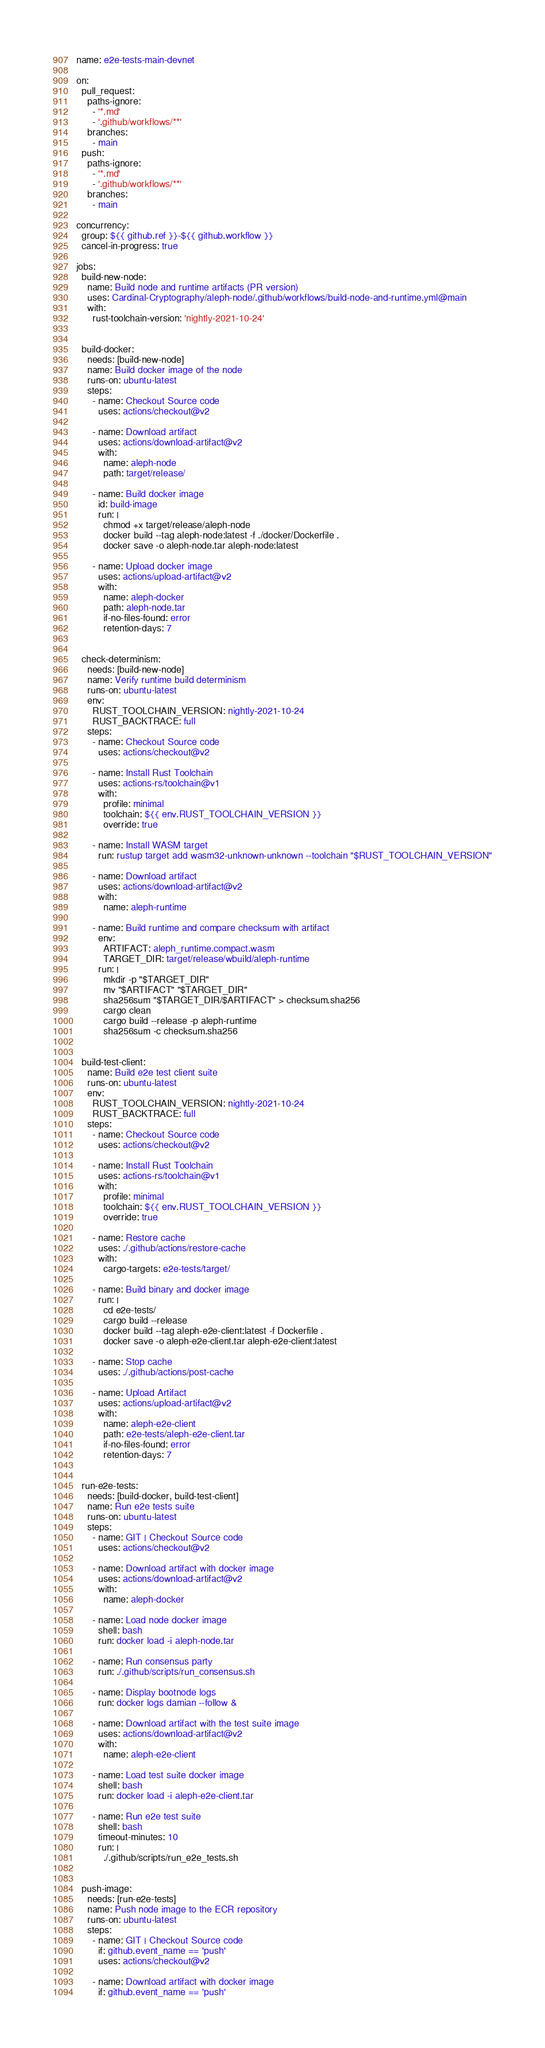Convert code to text. <code><loc_0><loc_0><loc_500><loc_500><_YAML_>name: e2e-tests-main-devnet

on:
  pull_request:
    paths-ignore:
      - '*.md'
      - '.github/workflows/**'
    branches:
      - main
  push:
    paths-ignore:
      - '*.md'
      - '.github/workflows/**'
    branches:
      - main

concurrency:
  group: ${{ github.ref }}-${{ github.workflow }}
  cancel-in-progress: true

jobs:
  build-new-node:
    name: Build node and runtime artifacts (PR version)
    uses: Cardinal-Cryptography/aleph-node/.github/workflows/build-node-and-runtime.yml@main
    with:
      rust-toolchain-version: 'nightly-2021-10-24'


  build-docker:
    needs: [build-new-node]
    name: Build docker image of the node
    runs-on: ubuntu-latest
    steps:
      - name: Checkout Source code
        uses: actions/checkout@v2

      - name: Download artifact
        uses: actions/download-artifact@v2
        with:
          name: aleph-node
          path: target/release/

      - name: Build docker image
        id: build-image
        run: |
          chmod +x target/release/aleph-node
          docker build --tag aleph-node:latest -f ./docker/Dockerfile .
          docker save -o aleph-node.tar aleph-node:latest

      - name: Upload docker image
        uses: actions/upload-artifact@v2
        with:
          name: aleph-docker
          path: aleph-node.tar
          if-no-files-found: error
          retention-days: 7


  check-determinism:
    needs: [build-new-node]
    name: Verify runtime build determinism
    runs-on: ubuntu-latest
    env:
      RUST_TOOLCHAIN_VERSION: nightly-2021-10-24
      RUST_BACKTRACE: full
    steps:
      - name: Checkout Source code
        uses: actions/checkout@v2

      - name: Install Rust Toolchain
        uses: actions-rs/toolchain@v1
        with:
          profile: minimal
          toolchain: ${{ env.RUST_TOOLCHAIN_VERSION }}
          override: true

      - name: Install WASM target
        run: rustup target add wasm32-unknown-unknown --toolchain "$RUST_TOOLCHAIN_VERSION"

      - name: Download artifact
        uses: actions/download-artifact@v2
        with:
          name: aleph-runtime

      - name: Build runtime and compare checksum with artifact
        env:
          ARTIFACT: aleph_runtime.compact.wasm
          TARGET_DIR: target/release/wbuild/aleph-runtime
        run: |
          mkdir -p "$TARGET_DIR"
          mv "$ARTIFACT" "$TARGET_DIR"
          sha256sum "$TARGET_DIR/$ARTIFACT" > checksum.sha256
          cargo clean
          cargo build --release -p aleph-runtime
          sha256sum -c checksum.sha256


  build-test-client:
    name: Build e2e test client suite
    runs-on: ubuntu-latest
    env:
      RUST_TOOLCHAIN_VERSION: nightly-2021-10-24
      RUST_BACKTRACE: full
    steps:
      - name: Checkout Source code
        uses: actions/checkout@v2

      - name: Install Rust Toolchain
        uses: actions-rs/toolchain@v1
        with:
          profile: minimal
          toolchain: ${{ env.RUST_TOOLCHAIN_VERSION }}
          override: true

      - name: Restore cache
        uses: ./.github/actions/restore-cache
        with:
          cargo-targets: e2e-tests/target/

      - name: Build binary and docker image
        run: |
          cd e2e-tests/
          cargo build --release
          docker build --tag aleph-e2e-client:latest -f Dockerfile .
          docker save -o aleph-e2e-client.tar aleph-e2e-client:latest

      - name: Stop cache
        uses: ./.github/actions/post-cache

      - name: Upload Artifact
        uses: actions/upload-artifact@v2
        with:
          name: aleph-e2e-client
          path: e2e-tests/aleph-e2e-client.tar
          if-no-files-found: error
          retention-days: 7


  run-e2e-tests:
    needs: [build-docker, build-test-client]
    name: Run e2e tests suite
    runs-on: ubuntu-latest
    steps:
      - name: GIT | Checkout Source code
        uses: actions/checkout@v2

      - name: Download artifact with docker image
        uses: actions/download-artifact@v2
        with:
          name: aleph-docker

      - name: Load node docker image
        shell: bash
        run: docker load -i aleph-node.tar

      - name: Run consensus party
        run: ./.github/scripts/run_consensus.sh

      - name: Display bootnode logs
        run: docker logs damian --follow &

      - name: Download artifact with the test suite image
        uses: actions/download-artifact@v2
        with:
          name: aleph-e2e-client

      - name: Load test suite docker image
        shell: bash
        run: docker load -i aleph-e2e-client.tar

      - name: Run e2e test suite
        shell: bash
        timeout-minutes: 10
        run: |
          ./.github/scripts/run_e2e_tests.sh


  push-image:
    needs: [run-e2e-tests]
    name: Push node image to the ECR repository
    runs-on: ubuntu-latest
    steps:
      - name: GIT | Checkout Source code
        if: github.event_name == 'push'
        uses: actions/checkout@v2

      - name: Download artifact with docker image
        if: github.event_name == 'push'</code> 